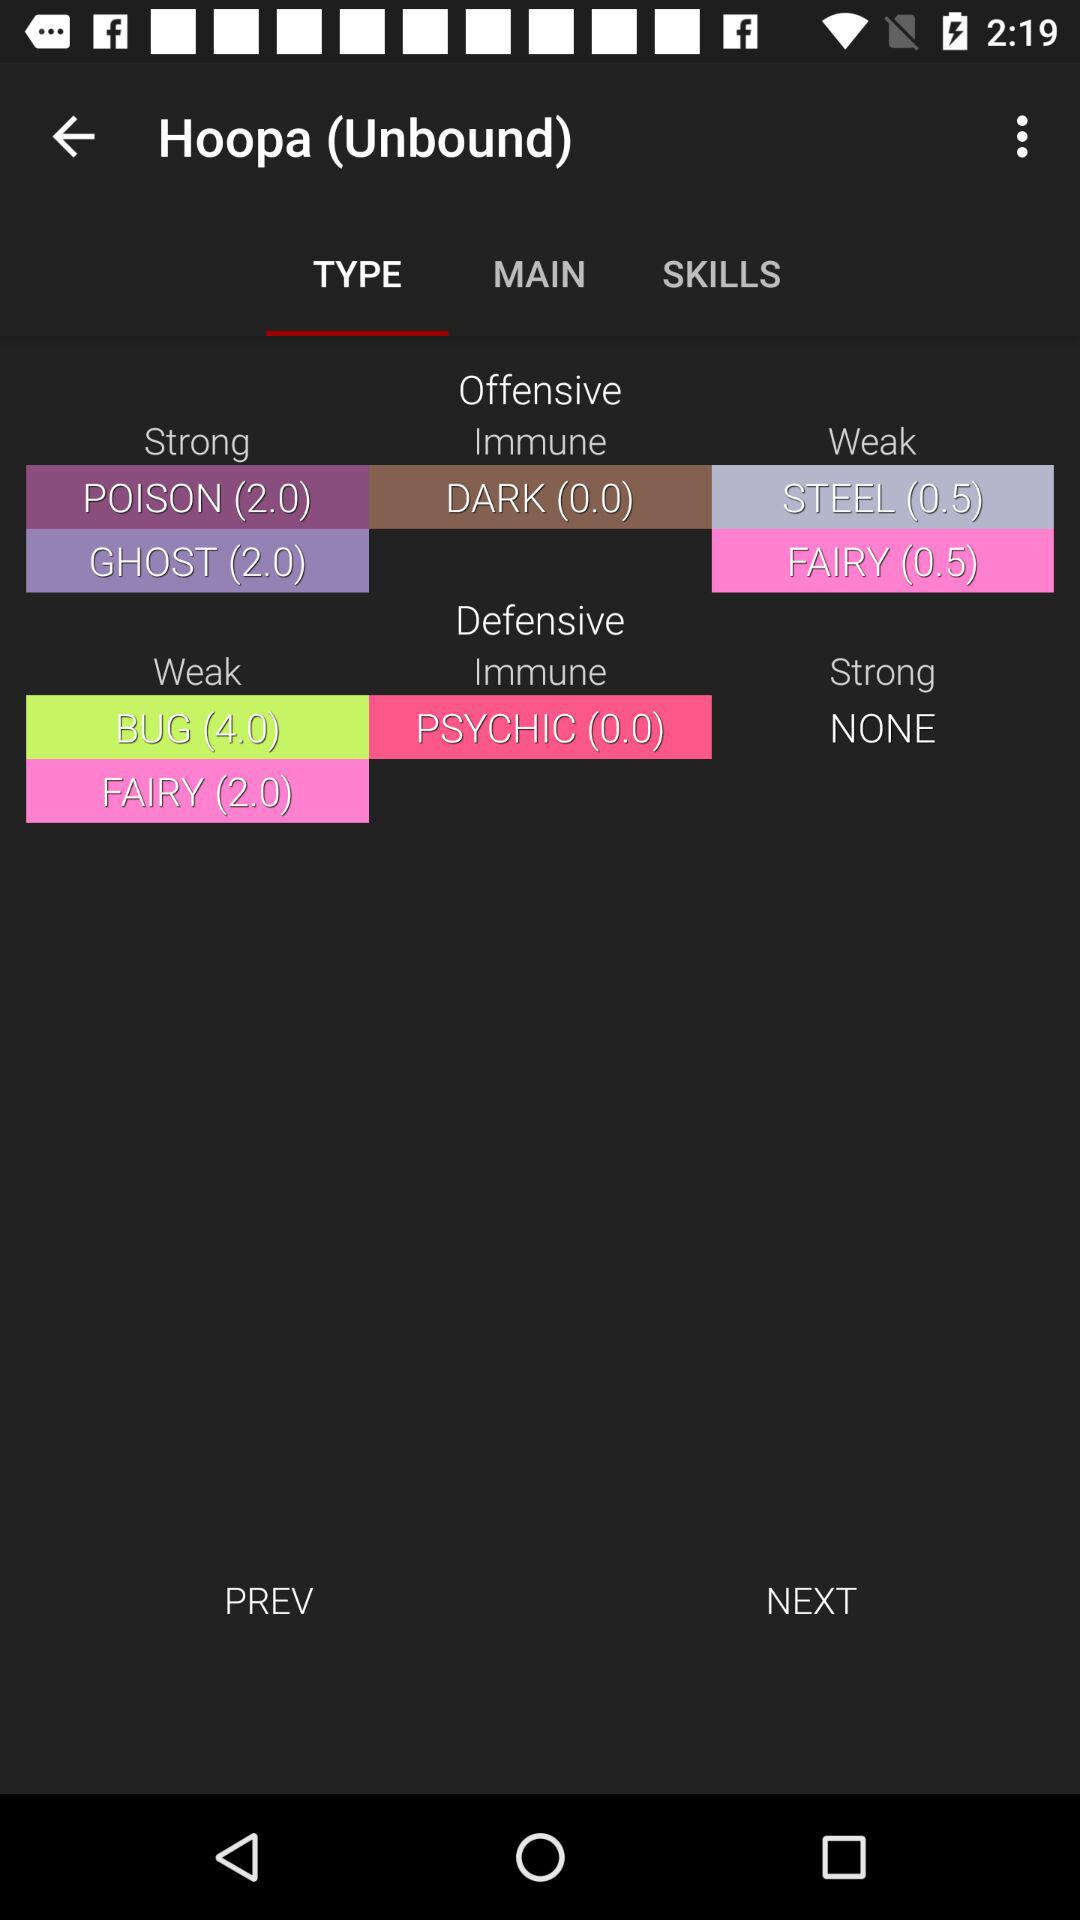How many offensive points does "Hoopa (Unbound)" have against "FAIRY" in the "Weak" category? "Hoopa (Unbound)" has 0.5 offensive points against "FAIRY" in the "Weak" category. 